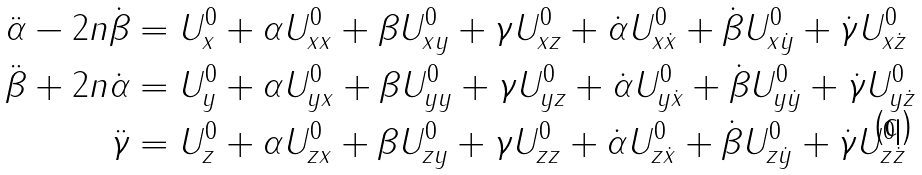Convert formula to latex. <formula><loc_0><loc_0><loc_500><loc_500>\ddot { \alpha } - 2 n \dot { \beta } & = { U ^ { 0 } _ { x } } + { \alpha } { U ^ { 0 } _ { x x } } + { \beta } { U ^ { 0 } _ { x y } } + { \gamma } { U ^ { 0 } _ { x z } } + \dot { \alpha } { U ^ { 0 } _ { x \dot { x } } } + { \dot { \beta } } { U ^ { 0 } _ { x \dot { y } } } + \dot { \gamma } { U ^ { 0 } _ { x \dot { z } } } \\ \ddot { \beta } + 2 n \dot { \alpha } & = { U ^ { 0 } _ { y } } + { \alpha } { U ^ { 0 } _ { y x } } + { \beta } { U ^ { 0 } _ { y y } } + { \gamma } { U ^ { 0 } _ { y z } } + \dot { \alpha } { U ^ { 0 } _ { y \dot { x } } } + \dot { \beta } { U ^ { 0 } _ { y \dot { y } } } + \dot { \gamma } { U ^ { 0 } _ { y \dot { z } } } \\ \ddot { \gamma } & = { U ^ { 0 } _ { z } } + { \alpha } { U ^ { 0 } _ { z x } } + { \beta } { U ^ { 0 } _ { z y } } + { \gamma } { U ^ { 0 } _ { z z } } + \dot { \alpha } { U ^ { 0 } _ { z \dot { x } } } + \dot { \beta } { U ^ { 0 } _ { z \dot { y } } } + \dot { \gamma } { U ^ { 0 } _ { z \dot { z } } }</formula> 